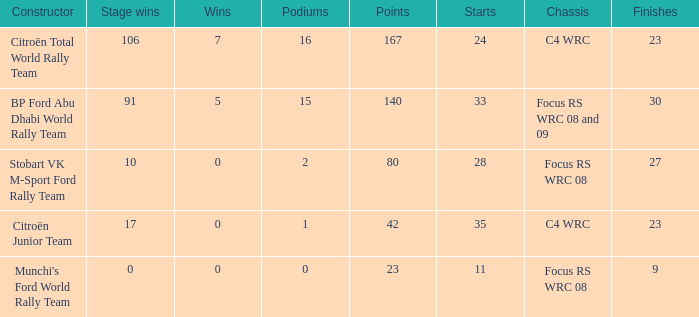What is the total number of points when the constructor is citroën total world rally team and the wins is less than 7? 0.0. 